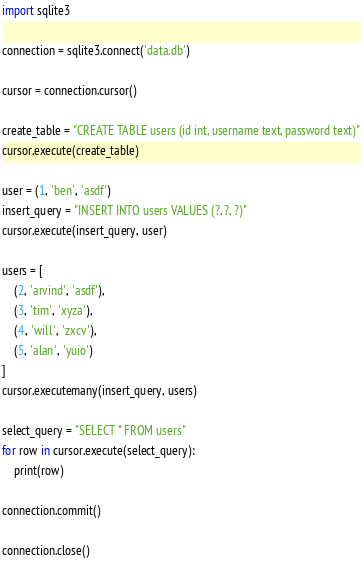Convert code to text. <code><loc_0><loc_0><loc_500><loc_500><_Python_>import sqlite3

connection = sqlite3.connect('data.db')

cursor = connection.cursor()

create_table = "CREATE TABLE users (id int, username text, password text)"
cursor.execute(create_table)

user = (1, 'ben', 'asdf')
insert_query = "INSERT INTO users VALUES (?, ?, ?)"
cursor.execute(insert_query, user)

users = [
	(2, 'arvind', 'asdf'),
	(3, 'tim', 'xyza'),
	(4, 'will', 'zxcv'),
	(5, 'alan', 'yuio')
]
cursor.executemany(insert_query, users)

select_query = "SELECT * FROM users"
for row in cursor.execute(select_query):
	print(row)

connection.commit()

connection.close()</code> 